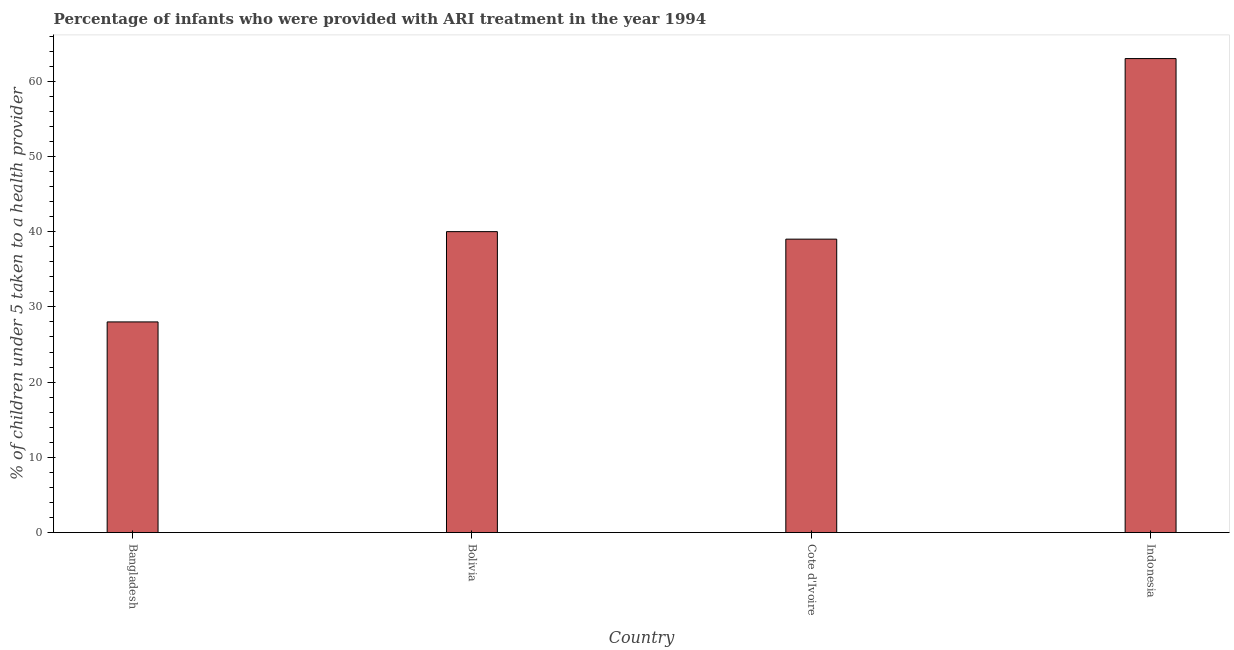What is the title of the graph?
Offer a very short reply. Percentage of infants who were provided with ARI treatment in the year 1994. What is the label or title of the X-axis?
Keep it short and to the point. Country. What is the label or title of the Y-axis?
Provide a succinct answer. % of children under 5 taken to a health provider. Across all countries, what is the maximum percentage of children who were provided with ari treatment?
Offer a very short reply. 63. In which country was the percentage of children who were provided with ari treatment minimum?
Your response must be concise. Bangladesh. What is the sum of the percentage of children who were provided with ari treatment?
Provide a short and direct response. 170. What is the median percentage of children who were provided with ari treatment?
Your answer should be very brief. 39.5. What is the ratio of the percentage of children who were provided with ari treatment in Bolivia to that in Cote d'Ivoire?
Provide a short and direct response. 1.03. Is the difference between the percentage of children who were provided with ari treatment in Bolivia and Indonesia greater than the difference between any two countries?
Your answer should be compact. No. What is the difference between the highest and the second highest percentage of children who were provided with ari treatment?
Give a very brief answer. 23. Is the sum of the percentage of children who were provided with ari treatment in Bangladesh and Indonesia greater than the maximum percentage of children who were provided with ari treatment across all countries?
Ensure brevity in your answer.  Yes. In how many countries, is the percentage of children who were provided with ari treatment greater than the average percentage of children who were provided with ari treatment taken over all countries?
Make the answer very short. 1. Are all the bars in the graph horizontal?
Make the answer very short. No. What is the difference between two consecutive major ticks on the Y-axis?
Provide a short and direct response. 10. Are the values on the major ticks of Y-axis written in scientific E-notation?
Provide a succinct answer. No. What is the % of children under 5 taken to a health provider in Cote d'Ivoire?
Give a very brief answer. 39. What is the % of children under 5 taken to a health provider in Indonesia?
Offer a very short reply. 63. What is the difference between the % of children under 5 taken to a health provider in Bangladesh and Indonesia?
Make the answer very short. -35. What is the difference between the % of children under 5 taken to a health provider in Bolivia and Cote d'Ivoire?
Ensure brevity in your answer.  1. What is the difference between the % of children under 5 taken to a health provider in Bolivia and Indonesia?
Make the answer very short. -23. What is the difference between the % of children under 5 taken to a health provider in Cote d'Ivoire and Indonesia?
Ensure brevity in your answer.  -24. What is the ratio of the % of children under 5 taken to a health provider in Bangladesh to that in Bolivia?
Ensure brevity in your answer.  0.7. What is the ratio of the % of children under 5 taken to a health provider in Bangladesh to that in Cote d'Ivoire?
Offer a very short reply. 0.72. What is the ratio of the % of children under 5 taken to a health provider in Bangladesh to that in Indonesia?
Keep it short and to the point. 0.44. What is the ratio of the % of children under 5 taken to a health provider in Bolivia to that in Cote d'Ivoire?
Give a very brief answer. 1.03. What is the ratio of the % of children under 5 taken to a health provider in Bolivia to that in Indonesia?
Ensure brevity in your answer.  0.64. What is the ratio of the % of children under 5 taken to a health provider in Cote d'Ivoire to that in Indonesia?
Offer a very short reply. 0.62. 